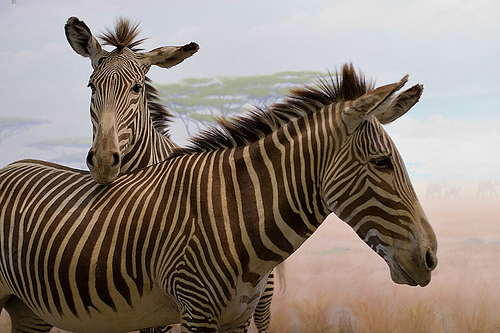Please provide the bounding box coordinate of the region this sentence describes: Head of a brown and white zebra that is pointing right. The coordinates [0.62, 0.31, 0.88, 0.74] skillfully encompass the head of a zebra, highlighted by its rich brown and white striped pattern and pointed ears attentive to its surroundings. 